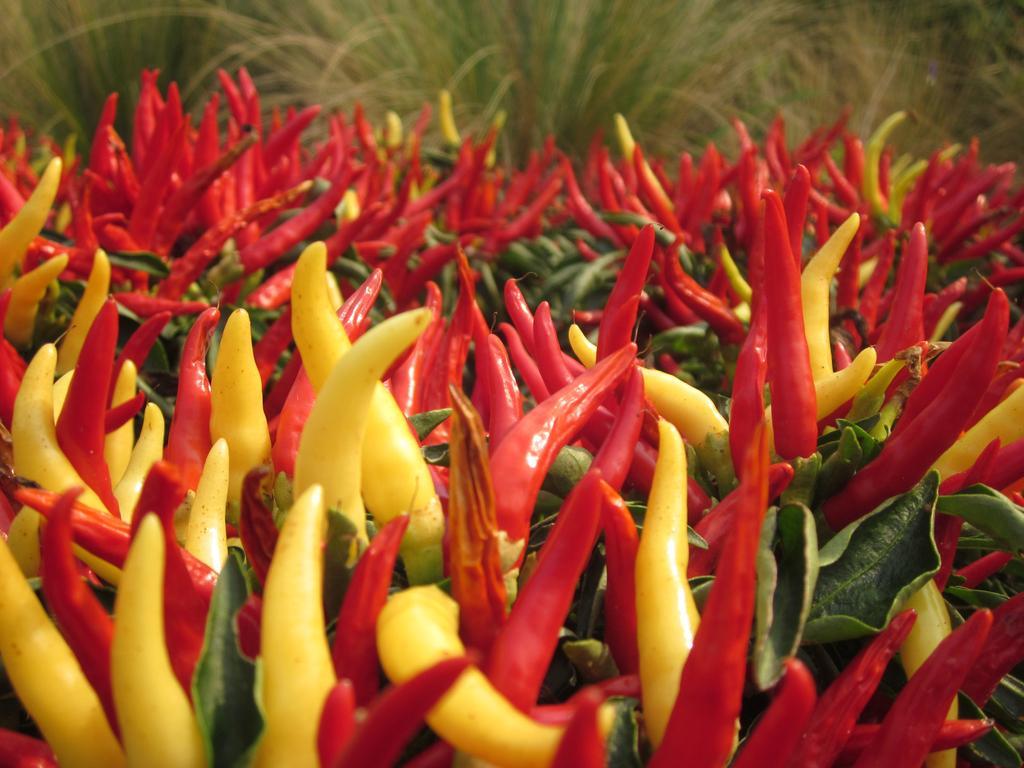In one or two sentences, can you explain what this image depicts? In this image I can see number of chilies which are red and yellow in color and I can see few leaves which are green in color. In the background I can see the grass. 